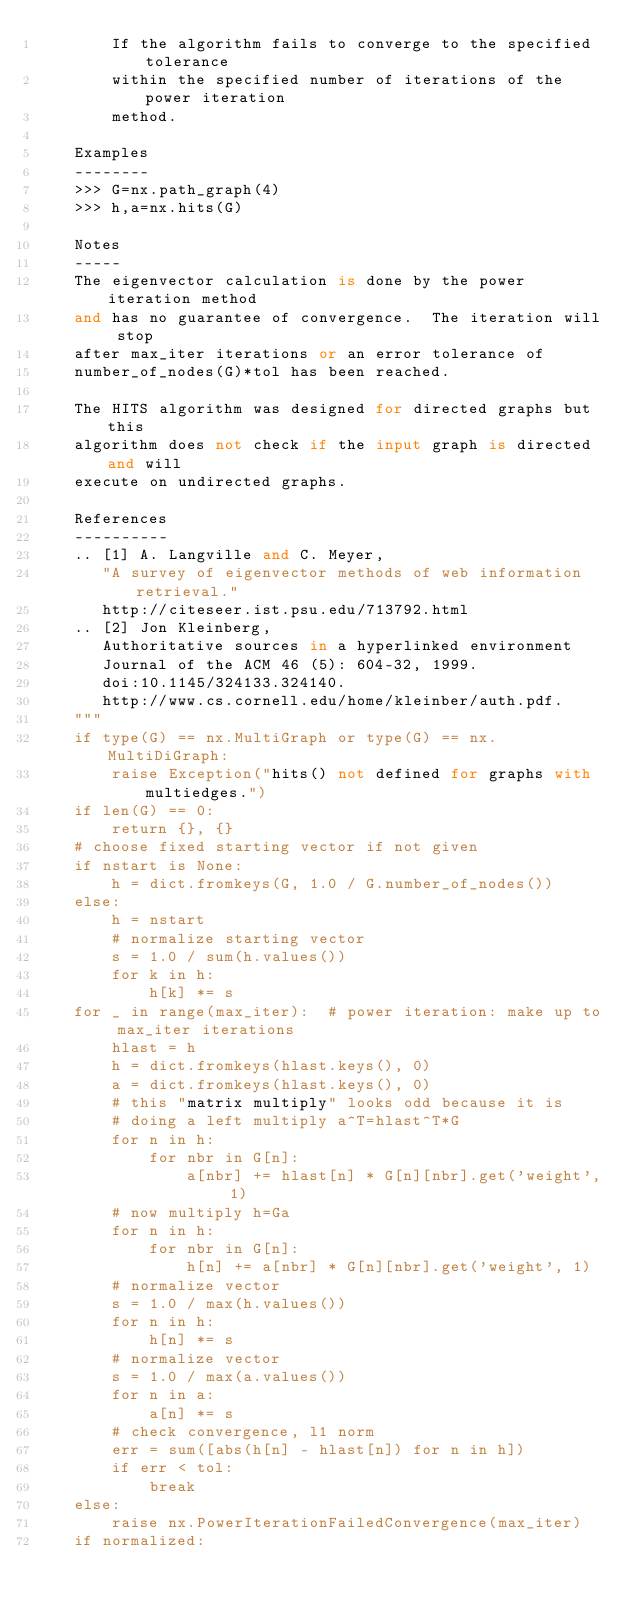Convert code to text. <code><loc_0><loc_0><loc_500><loc_500><_Python_>        If the algorithm fails to converge to the specified tolerance
        within the specified number of iterations of the power iteration
        method.

    Examples
    --------
    >>> G=nx.path_graph(4)
    >>> h,a=nx.hits(G)

    Notes
    -----
    The eigenvector calculation is done by the power iteration method
    and has no guarantee of convergence.  The iteration will stop
    after max_iter iterations or an error tolerance of
    number_of_nodes(G)*tol has been reached.

    The HITS algorithm was designed for directed graphs but this
    algorithm does not check if the input graph is directed and will
    execute on undirected graphs.

    References
    ----------
    .. [1] A. Langville and C. Meyer,
       "A survey of eigenvector methods of web information retrieval."
       http://citeseer.ist.psu.edu/713792.html
    .. [2] Jon Kleinberg,
       Authoritative sources in a hyperlinked environment
       Journal of the ACM 46 (5): 604-32, 1999.
       doi:10.1145/324133.324140.
       http://www.cs.cornell.edu/home/kleinber/auth.pdf.
    """
    if type(G) == nx.MultiGraph or type(G) == nx.MultiDiGraph:
        raise Exception("hits() not defined for graphs with multiedges.")
    if len(G) == 0:
        return {}, {}
    # choose fixed starting vector if not given
    if nstart is None:
        h = dict.fromkeys(G, 1.0 / G.number_of_nodes())
    else:
        h = nstart
        # normalize starting vector
        s = 1.0 / sum(h.values())
        for k in h:
            h[k] *= s
    for _ in range(max_iter):  # power iteration: make up to max_iter iterations
        hlast = h
        h = dict.fromkeys(hlast.keys(), 0)
        a = dict.fromkeys(hlast.keys(), 0)
        # this "matrix multiply" looks odd because it is
        # doing a left multiply a^T=hlast^T*G
        for n in h:
            for nbr in G[n]:
                a[nbr] += hlast[n] * G[n][nbr].get('weight', 1)
        # now multiply h=Ga
        for n in h:
            for nbr in G[n]:
                h[n] += a[nbr] * G[n][nbr].get('weight', 1)
        # normalize vector
        s = 1.0 / max(h.values())
        for n in h:
            h[n] *= s
        # normalize vector
        s = 1.0 / max(a.values())
        for n in a:
            a[n] *= s
        # check convergence, l1 norm
        err = sum([abs(h[n] - hlast[n]) for n in h])
        if err < tol:
            break
    else:
        raise nx.PowerIterationFailedConvergence(max_iter)
    if normalized:</code> 